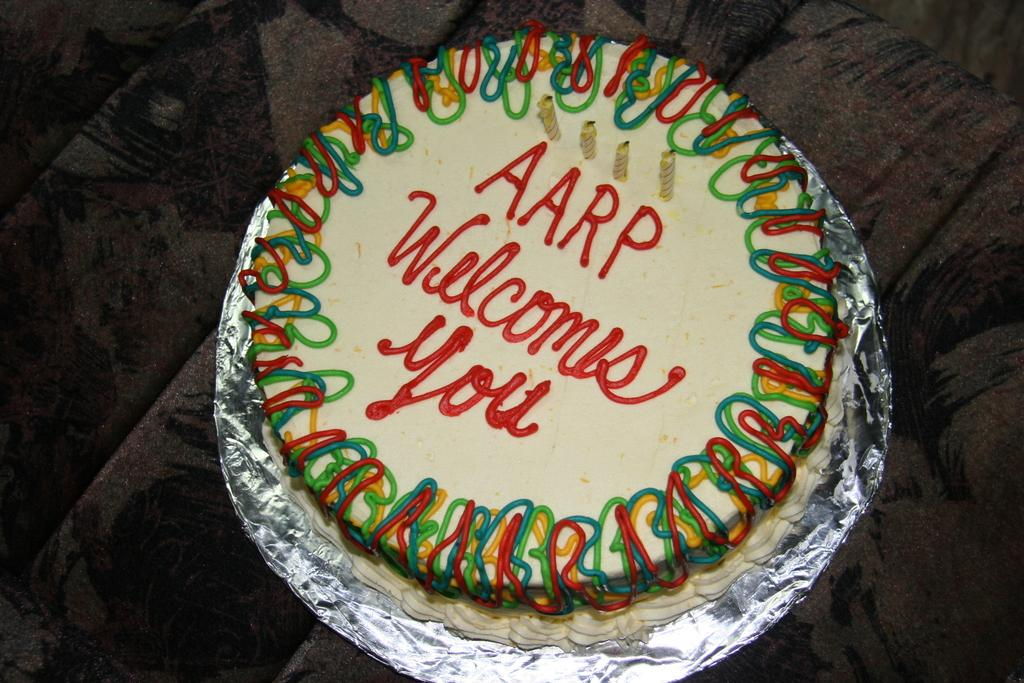What is the main subject of the image? There is a cake in the image. How many candles are on the cake? There are four candles on the cake. Is there any text or message on the cake? Yes, there is writing on the cake. What type of boats can be seen sailing near the cake in the image? There are no boats present in the image; it only features a cake with candles and writing. How many cows are visible in the image? There are no cows present in the image; it only features a cake with candles and writing. 